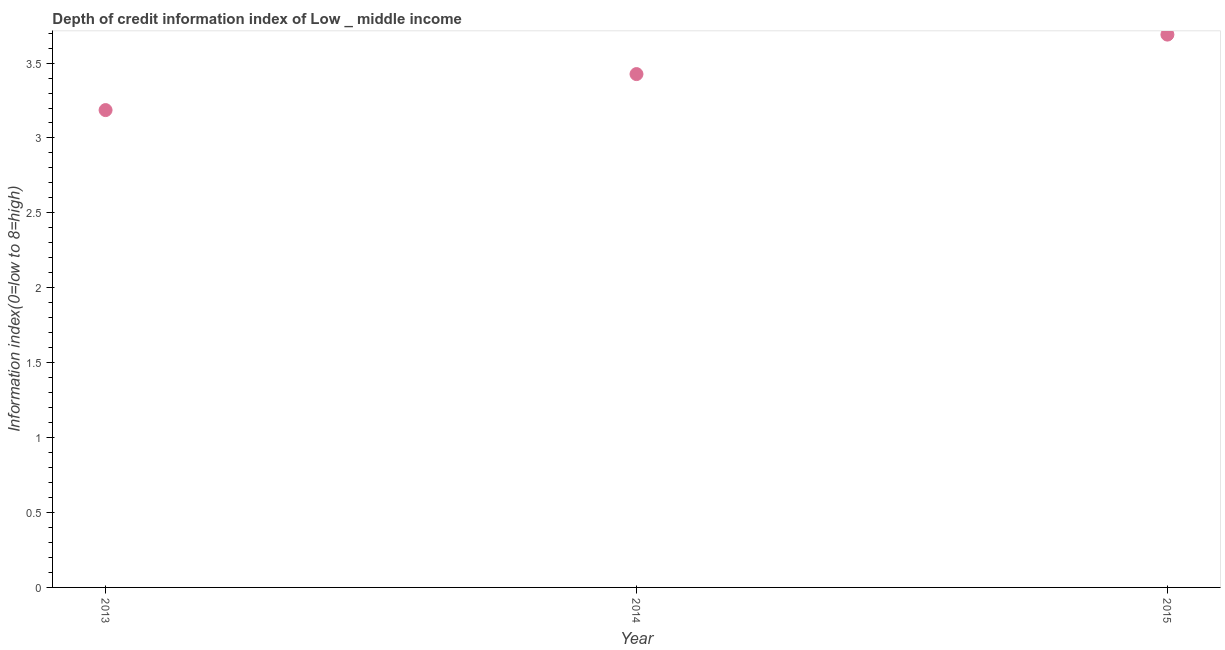What is the depth of credit information index in 2014?
Offer a terse response. 3.43. Across all years, what is the maximum depth of credit information index?
Ensure brevity in your answer.  3.69. Across all years, what is the minimum depth of credit information index?
Provide a succinct answer. 3.19. In which year was the depth of credit information index maximum?
Provide a succinct answer. 2015. In which year was the depth of credit information index minimum?
Your answer should be very brief. 2013. What is the sum of the depth of credit information index?
Make the answer very short. 10.3. What is the difference between the depth of credit information index in 2013 and 2014?
Your response must be concise. -0.24. What is the average depth of credit information index per year?
Offer a terse response. 3.43. What is the median depth of credit information index?
Keep it short and to the point. 3.43. What is the ratio of the depth of credit information index in 2013 to that in 2014?
Provide a short and direct response. 0.93. Is the difference between the depth of credit information index in 2014 and 2015 greater than the difference between any two years?
Ensure brevity in your answer.  No. What is the difference between the highest and the second highest depth of credit information index?
Offer a terse response. 0.26. Is the sum of the depth of credit information index in 2013 and 2015 greater than the maximum depth of credit information index across all years?
Your answer should be compact. Yes. What is the difference between the highest and the lowest depth of credit information index?
Your answer should be compact. 0.5. In how many years, is the depth of credit information index greater than the average depth of credit information index taken over all years?
Your answer should be compact. 1. How many dotlines are there?
Your answer should be compact. 1. What is the difference between two consecutive major ticks on the Y-axis?
Make the answer very short. 0.5. Does the graph contain grids?
Offer a terse response. No. What is the title of the graph?
Keep it short and to the point. Depth of credit information index of Low _ middle income. What is the label or title of the X-axis?
Offer a terse response. Year. What is the label or title of the Y-axis?
Your answer should be compact. Information index(0=low to 8=high). What is the Information index(0=low to 8=high) in 2013?
Offer a terse response. 3.19. What is the Information index(0=low to 8=high) in 2014?
Provide a succinct answer. 3.43. What is the Information index(0=low to 8=high) in 2015?
Ensure brevity in your answer.  3.69. What is the difference between the Information index(0=low to 8=high) in 2013 and 2014?
Give a very brief answer. -0.24. What is the difference between the Information index(0=low to 8=high) in 2013 and 2015?
Your answer should be compact. -0.5. What is the difference between the Information index(0=low to 8=high) in 2014 and 2015?
Your answer should be very brief. -0.26. What is the ratio of the Information index(0=low to 8=high) in 2013 to that in 2014?
Make the answer very short. 0.93. What is the ratio of the Information index(0=low to 8=high) in 2013 to that in 2015?
Make the answer very short. 0.86. What is the ratio of the Information index(0=low to 8=high) in 2014 to that in 2015?
Provide a short and direct response. 0.93. 